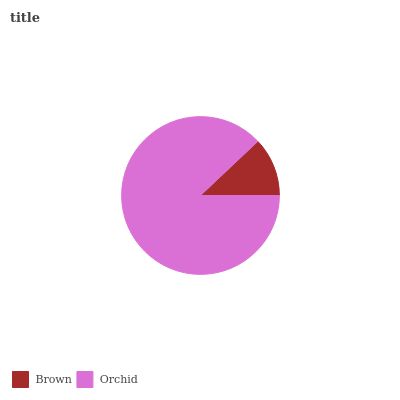Is Brown the minimum?
Answer yes or no. Yes. Is Orchid the maximum?
Answer yes or no. Yes. Is Orchid the minimum?
Answer yes or no. No. Is Orchid greater than Brown?
Answer yes or no. Yes. Is Brown less than Orchid?
Answer yes or no. Yes. Is Brown greater than Orchid?
Answer yes or no. No. Is Orchid less than Brown?
Answer yes or no. No. Is Orchid the high median?
Answer yes or no. Yes. Is Brown the low median?
Answer yes or no. Yes. Is Brown the high median?
Answer yes or no. No. Is Orchid the low median?
Answer yes or no. No. 